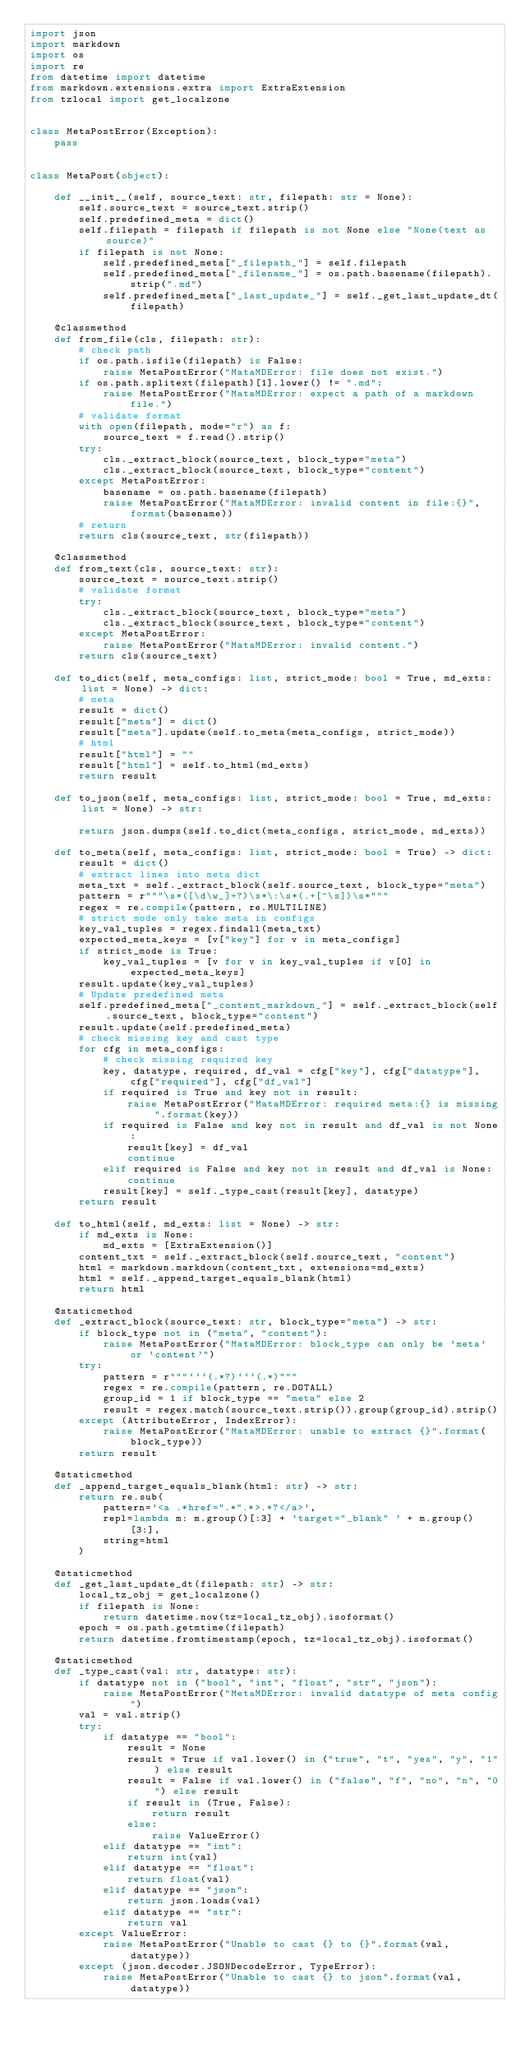Convert code to text. <code><loc_0><loc_0><loc_500><loc_500><_Python_>import json
import markdown
import os
import re
from datetime import datetime
from markdown.extensions.extra import ExtraExtension
from tzlocal import get_localzone


class MetaPostError(Exception):
    pass


class MetaPost(object):

    def __init__(self, source_text: str, filepath: str = None):
        self.source_text = source_text.strip()
        self.predefined_meta = dict()
        self.filepath = filepath if filepath is not None else "None(text as source)"
        if filepath is not None:
            self.predefined_meta["_filepath_"] = self.filepath
            self.predefined_meta["_filename_"] = os.path.basename(filepath).strip(".md")
            self.predefined_meta["_last_update_"] = self._get_last_update_dt(filepath)

    @classmethod
    def from_file(cls, filepath: str):
        # check path
        if os.path.isfile(filepath) is False:
            raise MetaPostError("MataMDError: file does not exist.")
        if os.path.splitext(filepath)[1].lower() != ".md":
            raise MetaPostError("MataMDError: expect a path of a markdown file.")
        # validate format
        with open(filepath, mode="r") as f:
            source_text = f.read().strip()
        try:
            cls._extract_block(source_text, block_type="meta")
            cls._extract_block(source_text, block_type="content")
        except MetaPostError:
            basename = os.path.basename(filepath)
            raise MetaPostError("MataMDError: invalid content in file:{}", format(basename))
        # return
        return cls(source_text, str(filepath))

    @classmethod
    def from_text(cls, source_text: str):
        source_text = source_text.strip()
        # validate format
        try:
            cls._extract_block(source_text, block_type="meta")
            cls._extract_block(source_text, block_type="content")
        except MetaPostError:
            raise MetaPostError("MataMDError: invalid content.")
        return cls(source_text)

    def to_dict(self, meta_configs: list, strict_mode: bool = True, md_exts: list = None) -> dict:
        # meta
        result = dict()
        result["meta"] = dict()
        result["meta"].update(self.to_meta(meta_configs, strict_mode))
        # html
        result["html"] = ""
        result["html"] = self.to_html(md_exts)
        return result

    def to_json(self, meta_configs: list, strict_mode: bool = True, md_exts: list = None) -> str:

        return json.dumps(self.to_dict(meta_configs, strict_mode, md_exts))

    def to_meta(self, meta_configs: list, strict_mode: bool = True) -> dict:
        result = dict()
        # extract lines into meta dict
        meta_txt = self._extract_block(self.source_text, block_type="meta")
        pattern = r"""\s*([\d\w_]+?)\s*\:\s*(.+[^\s])\s*"""
        regex = re.compile(pattern, re.MULTILINE)
        # strict mode only take meta in configs
        key_val_tuples = regex.findall(meta_txt)
        expected_meta_keys = [v["key"] for v in meta_configs]
        if strict_mode is True:
            key_val_tuples = [v for v in key_val_tuples if v[0] in expected_meta_keys]
        result.update(key_val_tuples)
        # Update predefined meta
        self.predefined_meta["_content_markdown_"] = self._extract_block(self.source_text, block_type="content")
        result.update(self.predefined_meta)
        # check missing key and cast type
        for cfg in meta_configs:
            # check missing required key
            key, datatype, required, df_val = cfg["key"], cfg["datatype"], cfg["required"], cfg["df_val"]
            if required is True and key not in result:
                raise MetaPostError("MataMDError: required meta:{} is missing".format(key))
            if required is False and key not in result and df_val is not None:
                result[key] = df_val
                continue
            elif required is False and key not in result and df_val is None:
                continue
            result[key] = self._type_cast(result[key], datatype)
        return result

    def to_html(self, md_exts: list = None) -> str:
        if md_exts is None:
            md_exts = [ExtraExtension()]
        content_txt = self._extract_block(self.source_text, "content")
        html = markdown.markdown(content_txt, extensions=md_exts)
        html = self._append_target_equals_blank(html)
        return html

    @staticmethod
    def _extract_block(source_text: str, block_type="meta") -> str:
        if block_type not in ("meta", "content"):
            raise MetaPostError("MataMDError: block_type can only be 'meta' or 'content'")
        try:
            pattern = r"""```(.*?)```(.*)"""
            regex = re.compile(pattern, re.DOTALL)
            group_id = 1 if block_type == "meta" else 2
            result = regex.match(source_text.strip()).group(group_id).strip()
        except (AttributeError, IndexError):
            raise MetaPostError("MataMDError: unable to extract {}".format(block_type))
        return result

    @staticmethod
    def _append_target_equals_blank(html: str) -> str:
        return re.sub(
            pattern='<a .*href=".*".*>.*?</a>',
            repl=lambda m: m.group()[:3] + 'target="_blank" ' + m.group()[3:],
            string=html
        )

    @staticmethod
    def _get_last_update_dt(filepath: str) -> str:
        local_tz_obj = get_localzone()
        if filepath is None:
            return datetime.now(tz=local_tz_obj).isoformat()
        epoch = os.path.getmtime(filepath)
        return datetime.fromtimestamp(epoch, tz=local_tz_obj).isoformat()

    @staticmethod
    def _type_cast(val: str, datatype: str):
        if datatype not in ("bool", "int", "float", "str", "json"):
            raise MetaPostError("MetaMDError: invalid datatype of meta config")
        val = val.strip()
        try:
            if datatype == "bool":
                result = None
                result = True if val.lower() in ("true", "t", "yes", "y", "1") else result
                result = False if val.lower() in ("false", "f", "no", "n", "0") else result
                if result in (True, False):
                    return result
                else:
                    raise ValueError()
            elif datatype == "int":
                return int(val)
            elif datatype == "float":
                return float(val)
            elif datatype == "json":
                return json.loads(val)
            elif datatype == "str":
                return val
        except ValueError:
            raise MetaPostError("Unable to cast {} to {}".format(val, datatype))
        except (json.decoder.JSONDecodeError, TypeError):
            raise MetaPostError("Unable to cast {} to json".format(val, datatype))
</code> 